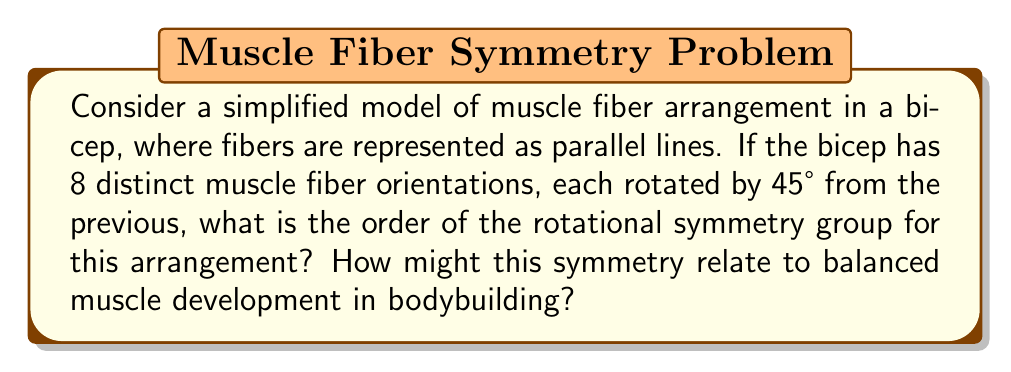Can you answer this question? To solve this problem, we need to understand the concept of rotational symmetry and how it applies to the given muscle fiber arrangement.

1) First, let's visualize the arrangement:
   The muscle fibers are arranged in 8 orientations, each 45° apart.
   This forms a symmetrical pattern that completes a full 360° rotation.

2) In group theory, rotational symmetry is described by the cyclic group $C_n$, where n is the number of distinct rotations that bring the object back to its original position.

3) In this case, we have 8 distinct orientations. A rotation of 45° (360°/8) will bring the arrangement to the next identical position.

4) Therefore, the symmetry group for this arrangement is $C_8$.

5) The order of a cyclic group $C_n$ is equal to n.

6) Thus, the order of the rotational symmetry group is 8.

Relating this to bodybuilding:
- This symmetrical arrangement suggests that the muscle fibers are evenly distributed in all directions.
- In bodybuilding, this could represent ideal muscle development, where force can be exerted equally in all directions.
- Bodybuilders often aim for symmetrical muscle development, as it's aesthetically pleasing and potentially more functional.
- Understanding these symmetries could help in designing balanced workout routines that target all aspects of the muscle equally.
Answer: The order of the rotational symmetry group is 8. This symmetry group is isomorphic to the cyclic group $C_8$. 